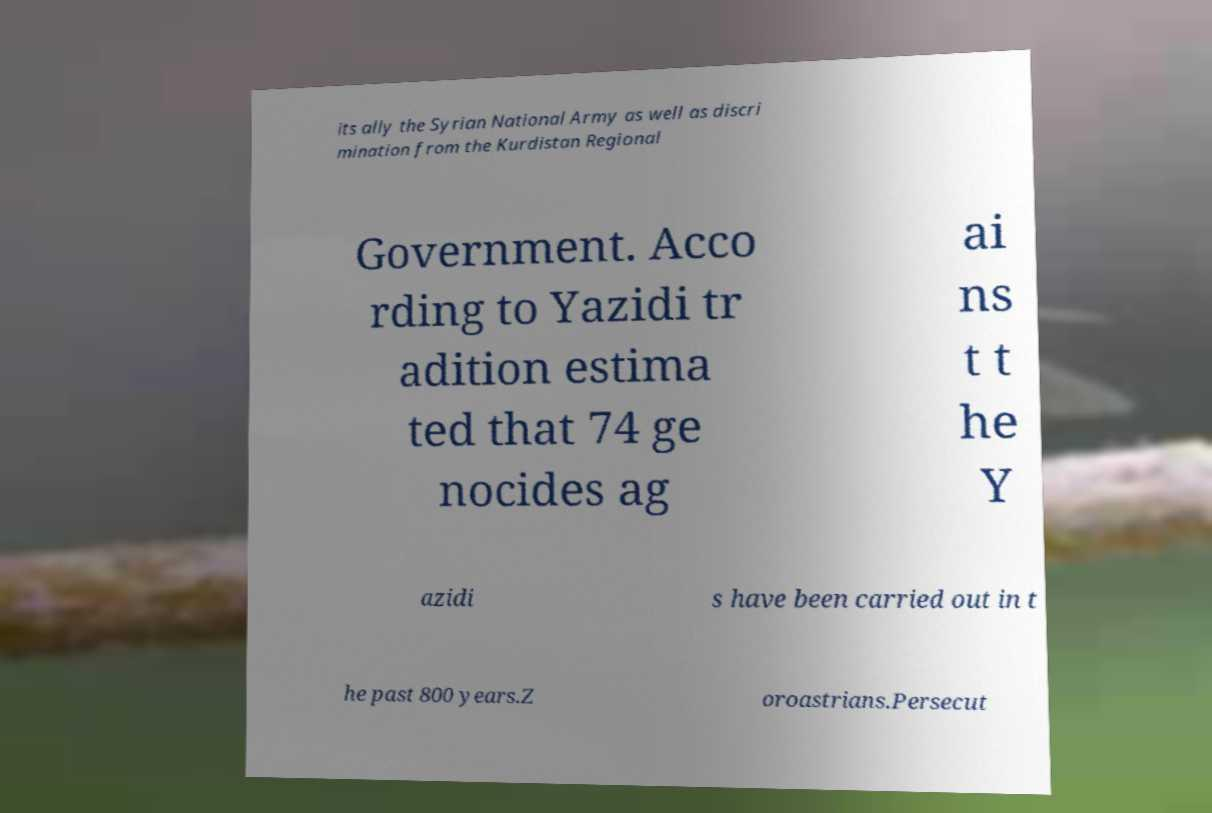Could you assist in decoding the text presented in this image and type it out clearly? its ally the Syrian National Army as well as discri mination from the Kurdistan Regional Government. Acco rding to Yazidi tr adition estima ted that 74 ge nocides ag ai ns t t he Y azidi s have been carried out in t he past 800 years.Z oroastrians.Persecut 